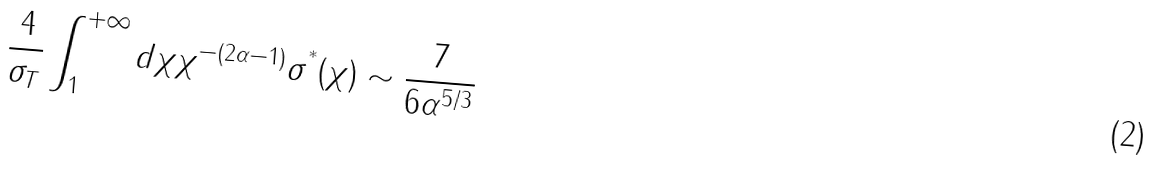Convert formula to latex. <formula><loc_0><loc_0><loc_500><loc_500>\frac { 4 } { \sigma _ { T } } \int _ { 1 } ^ { + \infty } d \chi \chi ^ { - ( 2 \alpha - 1 ) } \sigma ^ { ^ { * } } ( \chi ) \sim \frac { 7 } { 6 \alpha ^ { 5 / 3 } }</formula> 